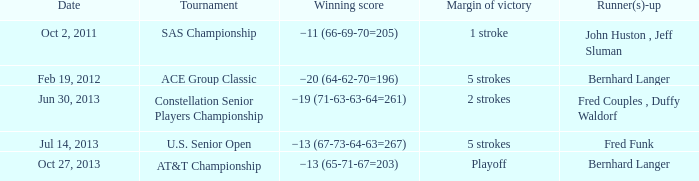When was fred funk a runner(s)-up in a competition? Jul 14, 2013. 